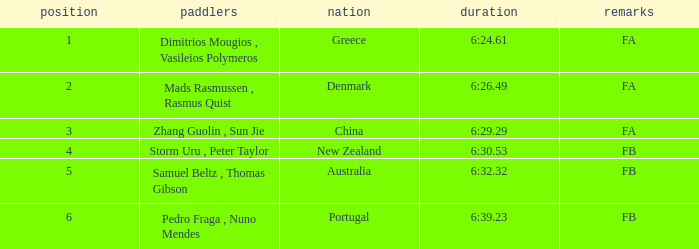What is the rank of the time of 6:30.53? 1.0. 